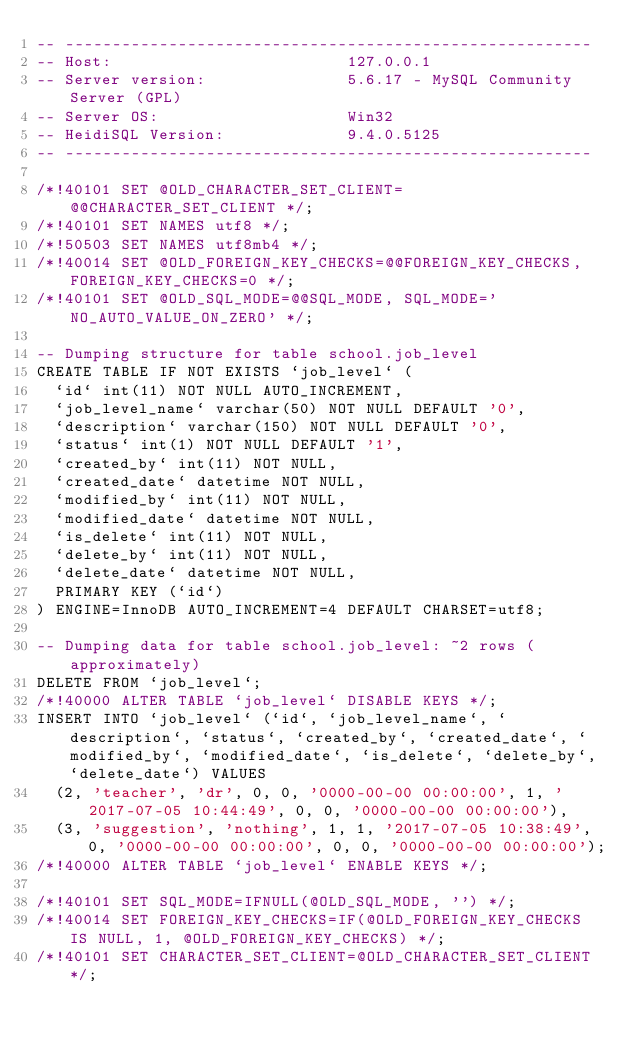<code> <loc_0><loc_0><loc_500><loc_500><_SQL_>-- --------------------------------------------------------
-- Host:                         127.0.0.1
-- Server version:               5.6.17 - MySQL Community Server (GPL)
-- Server OS:                    Win32
-- HeidiSQL Version:             9.4.0.5125
-- --------------------------------------------------------

/*!40101 SET @OLD_CHARACTER_SET_CLIENT=@@CHARACTER_SET_CLIENT */;
/*!40101 SET NAMES utf8 */;
/*!50503 SET NAMES utf8mb4 */;
/*!40014 SET @OLD_FOREIGN_KEY_CHECKS=@@FOREIGN_KEY_CHECKS, FOREIGN_KEY_CHECKS=0 */;
/*!40101 SET @OLD_SQL_MODE=@@SQL_MODE, SQL_MODE='NO_AUTO_VALUE_ON_ZERO' */;

-- Dumping structure for table school.job_level
CREATE TABLE IF NOT EXISTS `job_level` (
  `id` int(11) NOT NULL AUTO_INCREMENT,
  `job_level_name` varchar(50) NOT NULL DEFAULT '0',
  `description` varchar(150) NOT NULL DEFAULT '0',
  `status` int(1) NOT NULL DEFAULT '1',
  `created_by` int(11) NOT NULL,
  `created_date` datetime NOT NULL,
  `modified_by` int(11) NOT NULL,
  `modified_date` datetime NOT NULL,
  `is_delete` int(11) NOT NULL,
  `delete_by` int(11) NOT NULL,
  `delete_date` datetime NOT NULL,
  PRIMARY KEY (`id`)
) ENGINE=InnoDB AUTO_INCREMENT=4 DEFAULT CHARSET=utf8;

-- Dumping data for table school.job_level: ~2 rows (approximately)
DELETE FROM `job_level`;
/*!40000 ALTER TABLE `job_level` DISABLE KEYS */;
INSERT INTO `job_level` (`id`, `job_level_name`, `description`, `status`, `created_by`, `created_date`, `modified_by`, `modified_date`, `is_delete`, `delete_by`, `delete_date`) VALUES
	(2, 'teacher', 'dr', 0, 0, '0000-00-00 00:00:00', 1, '2017-07-05 10:44:49', 0, 0, '0000-00-00 00:00:00'),
	(3, 'suggestion', 'nothing', 1, 1, '2017-07-05 10:38:49', 0, '0000-00-00 00:00:00', 0, 0, '0000-00-00 00:00:00');
/*!40000 ALTER TABLE `job_level` ENABLE KEYS */;

/*!40101 SET SQL_MODE=IFNULL(@OLD_SQL_MODE, '') */;
/*!40014 SET FOREIGN_KEY_CHECKS=IF(@OLD_FOREIGN_KEY_CHECKS IS NULL, 1, @OLD_FOREIGN_KEY_CHECKS) */;
/*!40101 SET CHARACTER_SET_CLIENT=@OLD_CHARACTER_SET_CLIENT */;
</code> 